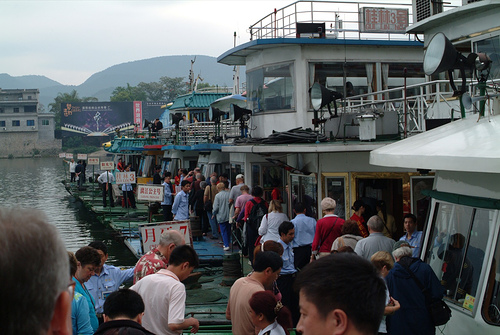<image>
Is there a man on the dock? Yes. Looking at the image, I can see the man is positioned on top of the dock, with the dock providing support. Is the man to the left of the house boat? No. The man is not to the left of the house boat. From this viewpoint, they have a different horizontal relationship. Is there a man to the left of the man? No. The man is not to the left of the man. From this viewpoint, they have a different horizontal relationship. 